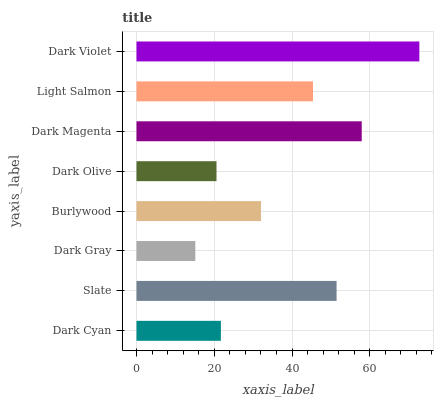Is Dark Gray the minimum?
Answer yes or no. Yes. Is Dark Violet the maximum?
Answer yes or no. Yes. Is Slate the minimum?
Answer yes or no. No. Is Slate the maximum?
Answer yes or no. No. Is Slate greater than Dark Cyan?
Answer yes or no. Yes. Is Dark Cyan less than Slate?
Answer yes or no. Yes. Is Dark Cyan greater than Slate?
Answer yes or no. No. Is Slate less than Dark Cyan?
Answer yes or no. No. Is Light Salmon the high median?
Answer yes or no. Yes. Is Burlywood the low median?
Answer yes or no. Yes. Is Dark Violet the high median?
Answer yes or no. No. Is Slate the low median?
Answer yes or no. No. 